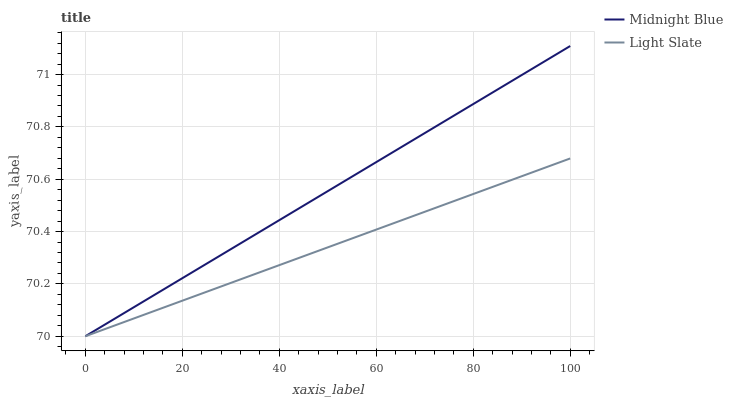Does Light Slate have the minimum area under the curve?
Answer yes or no. Yes. Does Midnight Blue have the maximum area under the curve?
Answer yes or no. Yes. Does Midnight Blue have the minimum area under the curve?
Answer yes or no. No. Is Midnight Blue the smoothest?
Answer yes or no. Yes. Is Light Slate the roughest?
Answer yes or no. Yes. Is Midnight Blue the roughest?
Answer yes or no. No. Does Midnight Blue have the highest value?
Answer yes or no. Yes. Does Light Slate intersect Midnight Blue?
Answer yes or no. Yes. Is Light Slate less than Midnight Blue?
Answer yes or no. No. Is Light Slate greater than Midnight Blue?
Answer yes or no. No. 